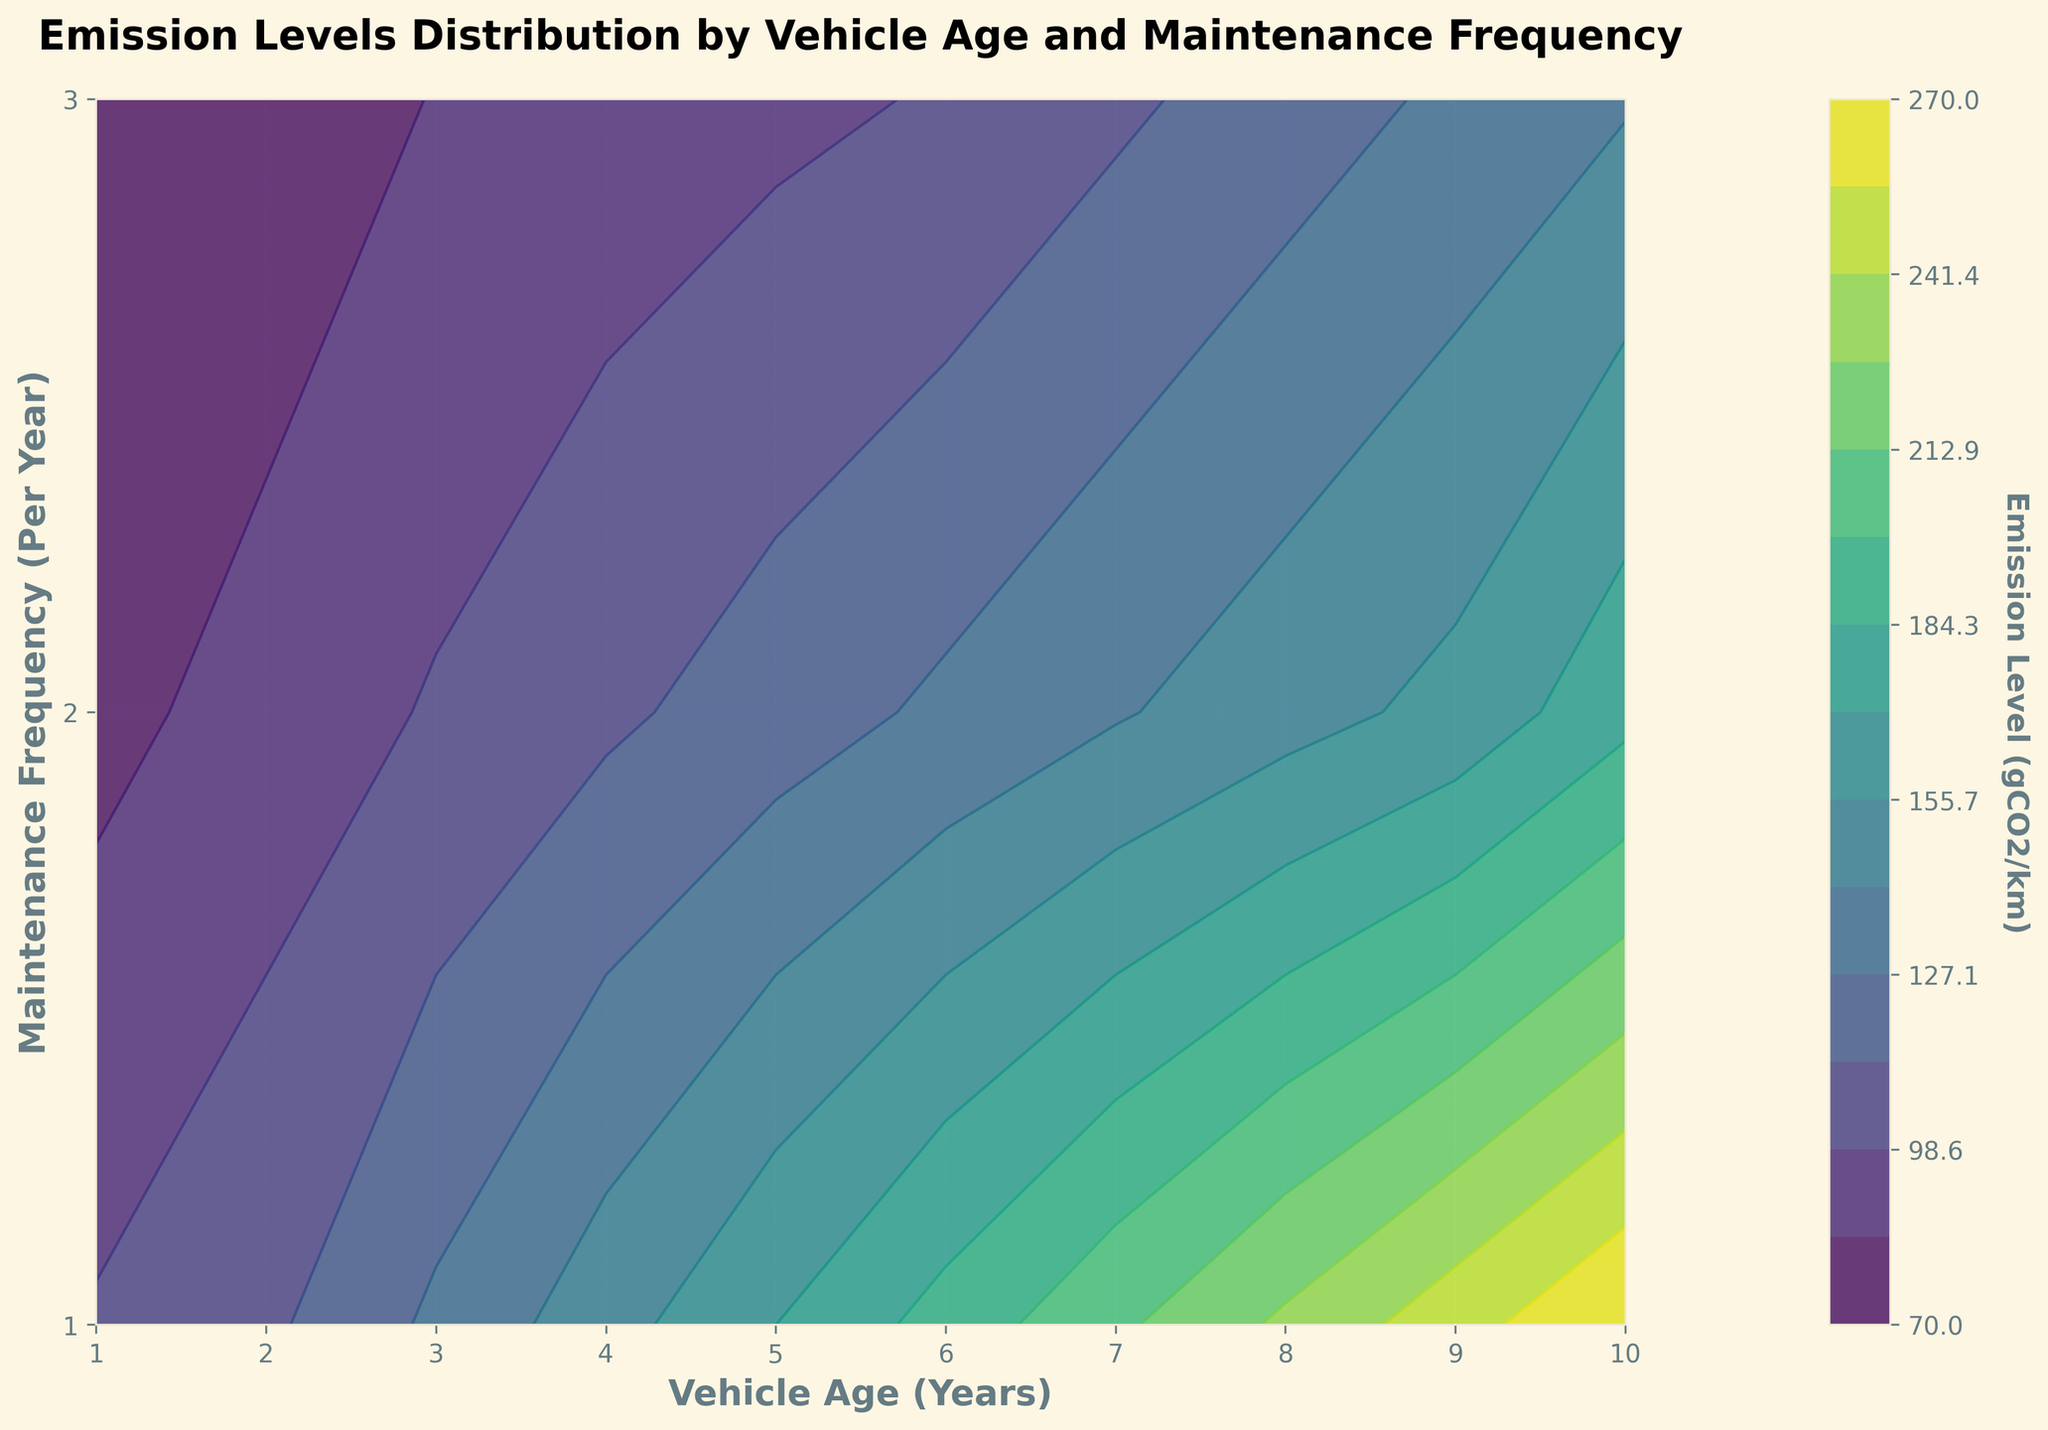What is the title of the plot? The title is typically displayed at the top of the plot and helps understand the focus of the figure.
Answer: Emission Levels Distribution by Vehicle Age and Maintenance Frequency What is the X-axis representing? The X-axis label provides information about the variable plotted along the horizontal axis.
Answer: Vehicle Age (Years) What is the Y-axis representing? The Y-axis label provides information about the variable plotted along the vertical axis.
Answer: Maintenance Frequency (Per Year) What is the lowest emission level visible on this contour plot? The color bar provides a range of emission levels, with the lowest corresponding to the lightest color in the contour.
Answer: 70 gCO2/km How does emission level change with vehicle age for a maintenance frequency of 2 times per year? Observing the contour lines along the Y-axis value of 2 (Maintenance Frequency) for increasing X-axis values (Vehicle Age) shows how emission levels change.
Answer: It generally increases What maintenance frequency shows the lowest emissions for a vehicle age of 5 years? By following the 5-year mark on the X-axis and observing which contour level has the lowest emissions.
Answer: 3 times per year Is there any range of vehicle age where emissions are consistently high regardless of maintenance frequency? Checking for contour regions where emissions are high across all Y-axis values (Maintenance Frequency) over a range of X-axis values (Vehicle Age).
Answer: 8 to 10 years For a vehicle aged 1 year, how does increasing the maintenance frequency affect the emissions? Observing the contour levels from the left end of the plot (Vehicle Age = 1 year) for increasing Y-axis values (Maintenance Frequency).
Answer: It decreases emissions Which combination of vehicle age and maintenance frequency results in the highest emission level? Identifying the highest contour level in the plot and checking corresponding X and Y values.
Answer: 10 years and 1 time per year How are the emission levels distributed for vehicles aged 7 years? Examining the contour lines around the X-axis value of 7 years across different maintenance frequencies.
Answer: They vary between 110 and 210 gCO2/km 